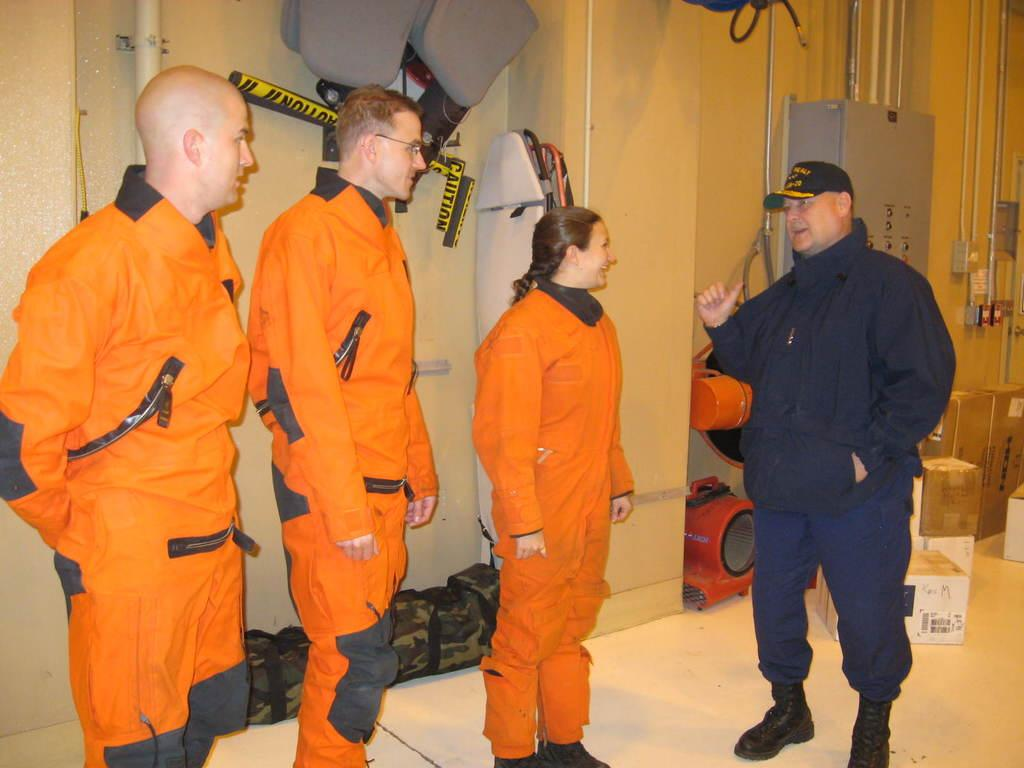How many people are present in the image? There are four people standing in the image. What are the people wearing? The people are wearing uniforms. What can be seen in the background of the image? There are pipes and bags on the ground in the background of the image. What else is present on the ground in the background of the image? There are other objects on the ground in the background of the image. How much profit did the people make in the image? There is no information about profit in the image, as it focuses on the people and their surroundings. 